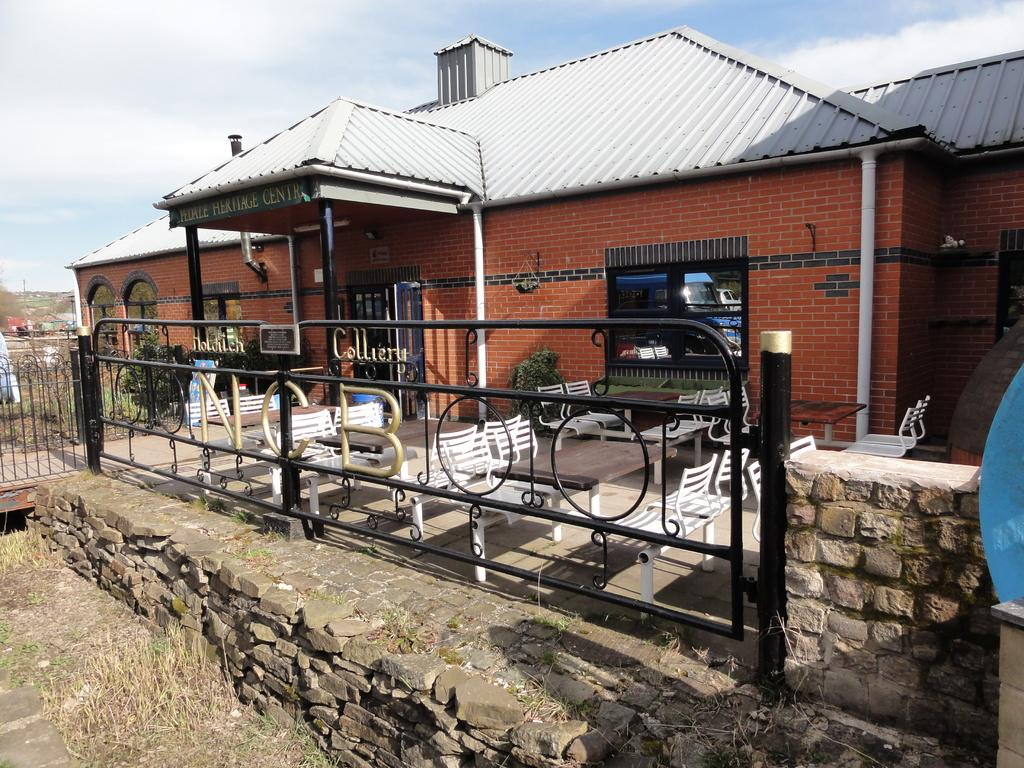What type of structure is shown in the image? There is a building in the image. What might the building be used for? The building appears to be a restaurant. What can be seen in front of the building? There is a black color railing in front of the building. What is visible in the background of the image? The sky is visible in the background of the image. What brand of toothpaste is advertised on the building in the image? There is no toothpaste advertised on the building in the image. What is the level of interest in the building among potential customers? The level of interest in the building among potential customers cannot be determined from the image alone. 